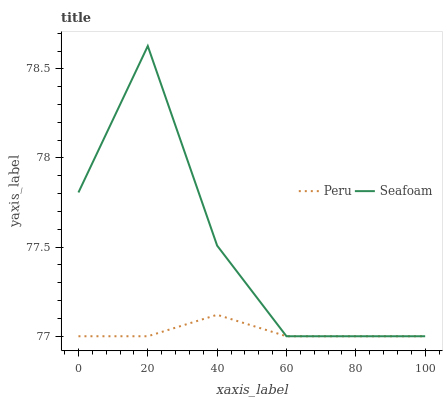Does Peru have the minimum area under the curve?
Answer yes or no. Yes. Does Seafoam have the maximum area under the curve?
Answer yes or no. Yes. Does Peru have the maximum area under the curve?
Answer yes or no. No. Is Peru the smoothest?
Answer yes or no. Yes. Is Seafoam the roughest?
Answer yes or no. Yes. Is Peru the roughest?
Answer yes or no. No. Does Seafoam have the lowest value?
Answer yes or no. Yes. Does Seafoam have the highest value?
Answer yes or no. Yes. Does Peru have the highest value?
Answer yes or no. No. Does Seafoam intersect Peru?
Answer yes or no. Yes. Is Seafoam less than Peru?
Answer yes or no. No. Is Seafoam greater than Peru?
Answer yes or no. No. 